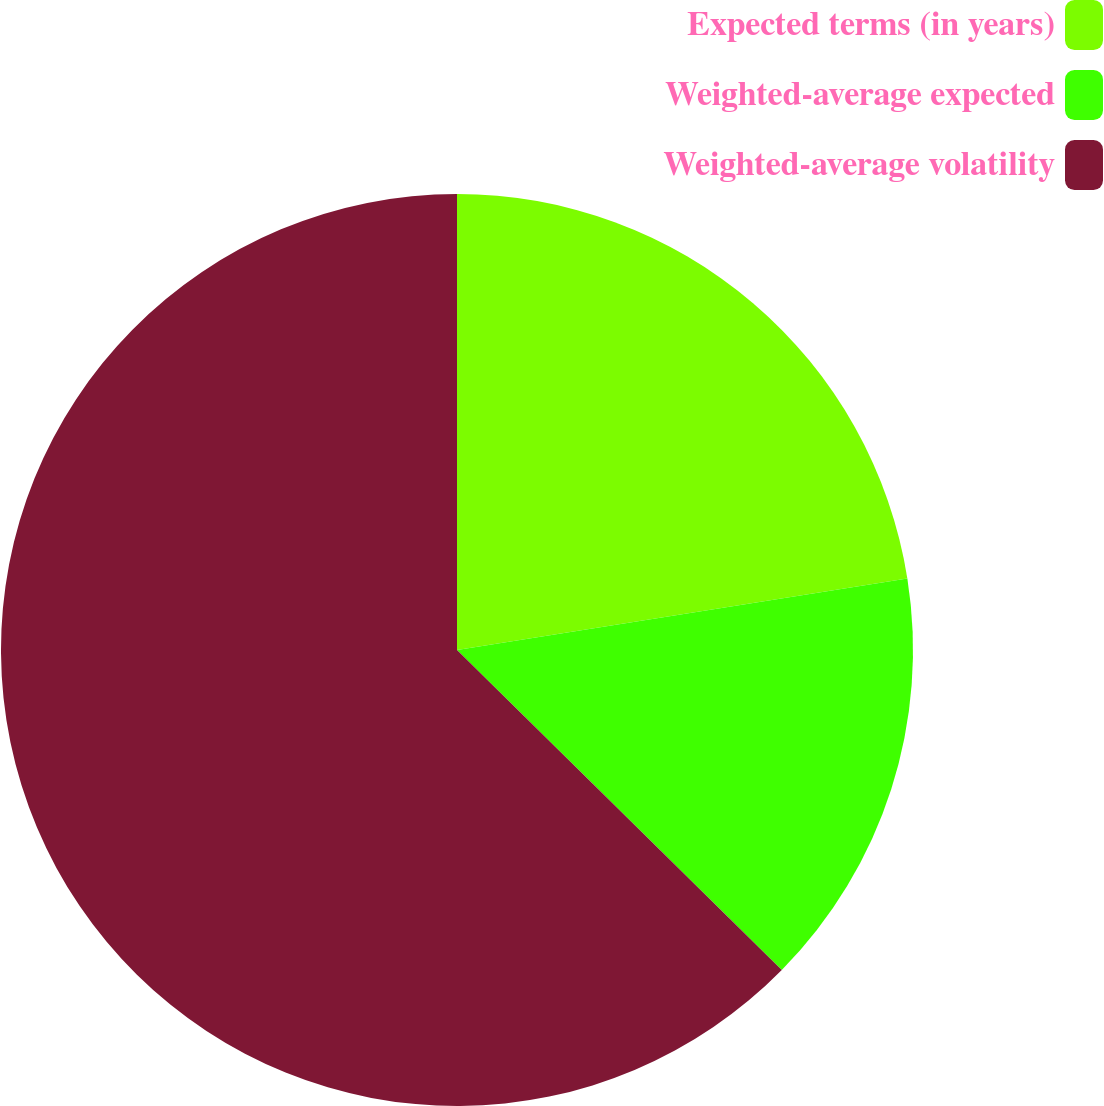Convert chart. <chart><loc_0><loc_0><loc_500><loc_500><pie_chart><fcel>Expected terms (in years)<fcel>Weighted-average expected<fcel>Weighted-average volatility<nl><fcel>22.49%<fcel>14.89%<fcel>62.61%<nl></chart> 